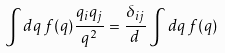<formula> <loc_0><loc_0><loc_500><loc_500>\int d { q } \, f ( q ) \frac { q _ { i } q _ { j } } { q ^ { 2 } } = \frac { \delta _ { i j } } { d } \int d { q } \, f ( q )</formula> 